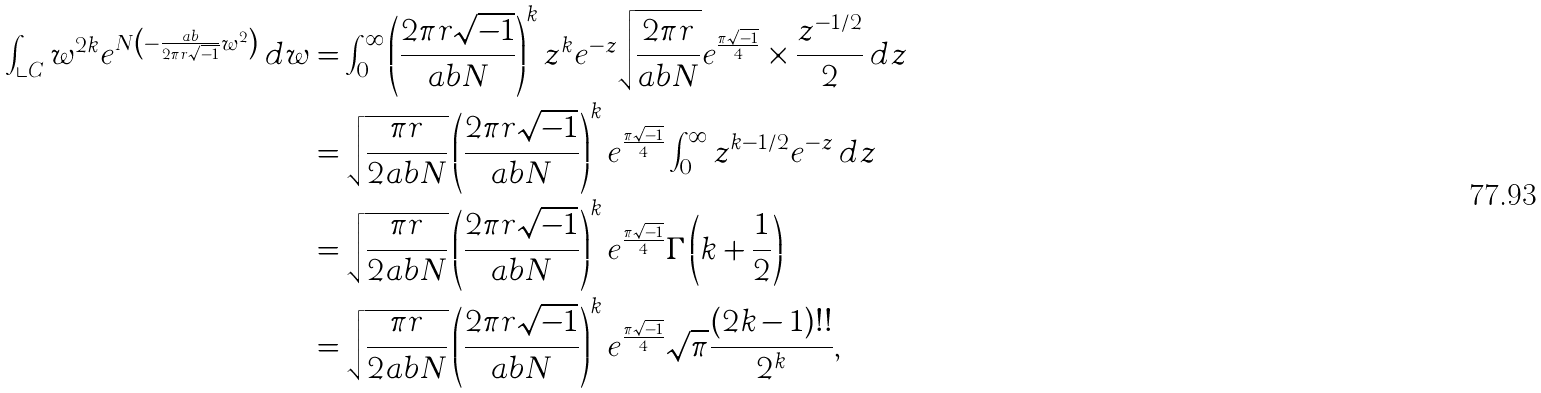<formula> <loc_0><loc_0><loc_500><loc_500>\int _ { \llcorner { C } } w ^ { 2 k } e ^ { N \left ( - \frac { a b } { 2 \pi { r } \sqrt { - 1 } } w ^ { 2 } \right ) } \, d w & = \int _ { 0 } ^ { \infty } \left ( \frac { 2 \pi { r } \sqrt { - 1 } } { a b N } \right ) ^ { k } z ^ { k } e ^ { - z } \sqrt { \frac { 2 \pi { r } } { a b N } } e ^ { \frac { \pi \sqrt { - 1 } } { 4 } } \times \frac { z ^ { - 1 / 2 } } { 2 } \, d z \\ & = \sqrt { \frac { \pi { r } } { 2 a b N } } \left ( \frac { 2 \pi { r } \sqrt { - 1 } } { a b N } \right ) ^ { k } e ^ { \frac { \pi \sqrt { - 1 } } { 4 } } \int _ { 0 } ^ { \infty } z ^ { k - 1 / 2 } e ^ { - z } \, d z \\ & = \sqrt { \frac { \pi { r } } { 2 a b N } } \left ( \frac { 2 \pi { r } \sqrt { - 1 } } { a b N } \right ) ^ { k } e ^ { \frac { \pi \sqrt { - 1 } } { 4 } } \Gamma \left ( k + \frac { 1 } { 2 } \right ) \\ & = \sqrt { \frac { \pi { r } } { 2 a b N } } \left ( \frac { 2 \pi { r } \sqrt { - 1 } } { a b N } \right ) ^ { k } e ^ { \frac { \pi \sqrt { - 1 } } { 4 } } \sqrt { \pi } \frac { ( 2 k - 1 ) ! ! } { 2 ^ { k } } ,</formula> 